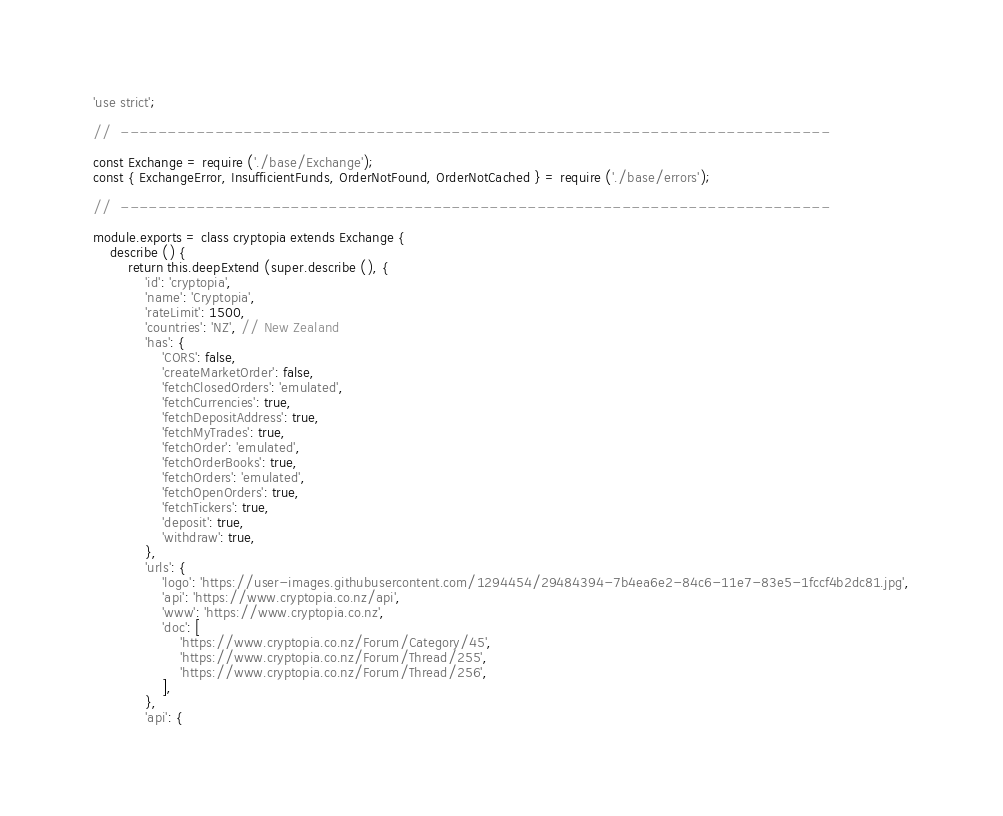<code> <loc_0><loc_0><loc_500><loc_500><_JavaScript_>'use strict';

//  ---------------------------------------------------------------------------

const Exchange = require ('./base/Exchange');
const { ExchangeError, InsufficientFunds, OrderNotFound, OrderNotCached } = require ('./base/errors');

//  ---------------------------------------------------------------------------

module.exports = class cryptopia extends Exchange {
    describe () {
        return this.deepExtend (super.describe (), {
            'id': 'cryptopia',
            'name': 'Cryptopia',
            'rateLimit': 1500,
            'countries': 'NZ', // New Zealand
            'has': {
                'CORS': false,
                'createMarketOrder': false,
                'fetchClosedOrders': 'emulated',
                'fetchCurrencies': true,
                'fetchDepositAddress': true,
                'fetchMyTrades': true,
                'fetchOrder': 'emulated',
                'fetchOrderBooks': true,
                'fetchOrders': 'emulated',
                'fetchOpenOrders': true,
                'fetchTickers': true,
                'deposit': true,
                'withdraw': true,
            },
            'urls': {
                'logo': 'https://user-images.githubusercontent.com/1294454/29484394-7b4ea6e2-84c6-11e7-83e5-1fccf4b2dc81.jpg',
                'api': 'https://www.cryptopia.co.nz/api',
                'www': 'https://www.cryptopia.co.nz',
                'doc': [
                    'https://www.cryptopia.co.nz/Forum/Category/45',
                    'https://www.cryptopia.co.nz/Forum/Thread/255',
                    'https://www.cryptopia.co.nz/Forum/Thread/256',
                ],
            },
            'api': {</code> 